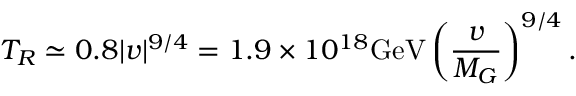<formula> <loc_0><loc_0><loc_500><loc_500>T _ { R } \simeq 0 . 8 | v | ^ { 9 / 4 } = 1 . 9 \times 1 0 ^ { 1 8 } G e V \left ( \frac { v } { M _ { G } } \right ) ^ { 9 / 4 } .</formula> 